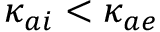<formula> <loc_0><loc_0><loc_500><loc_500>\kappa _ { a i } < \kappa _ { a e }</formula> 